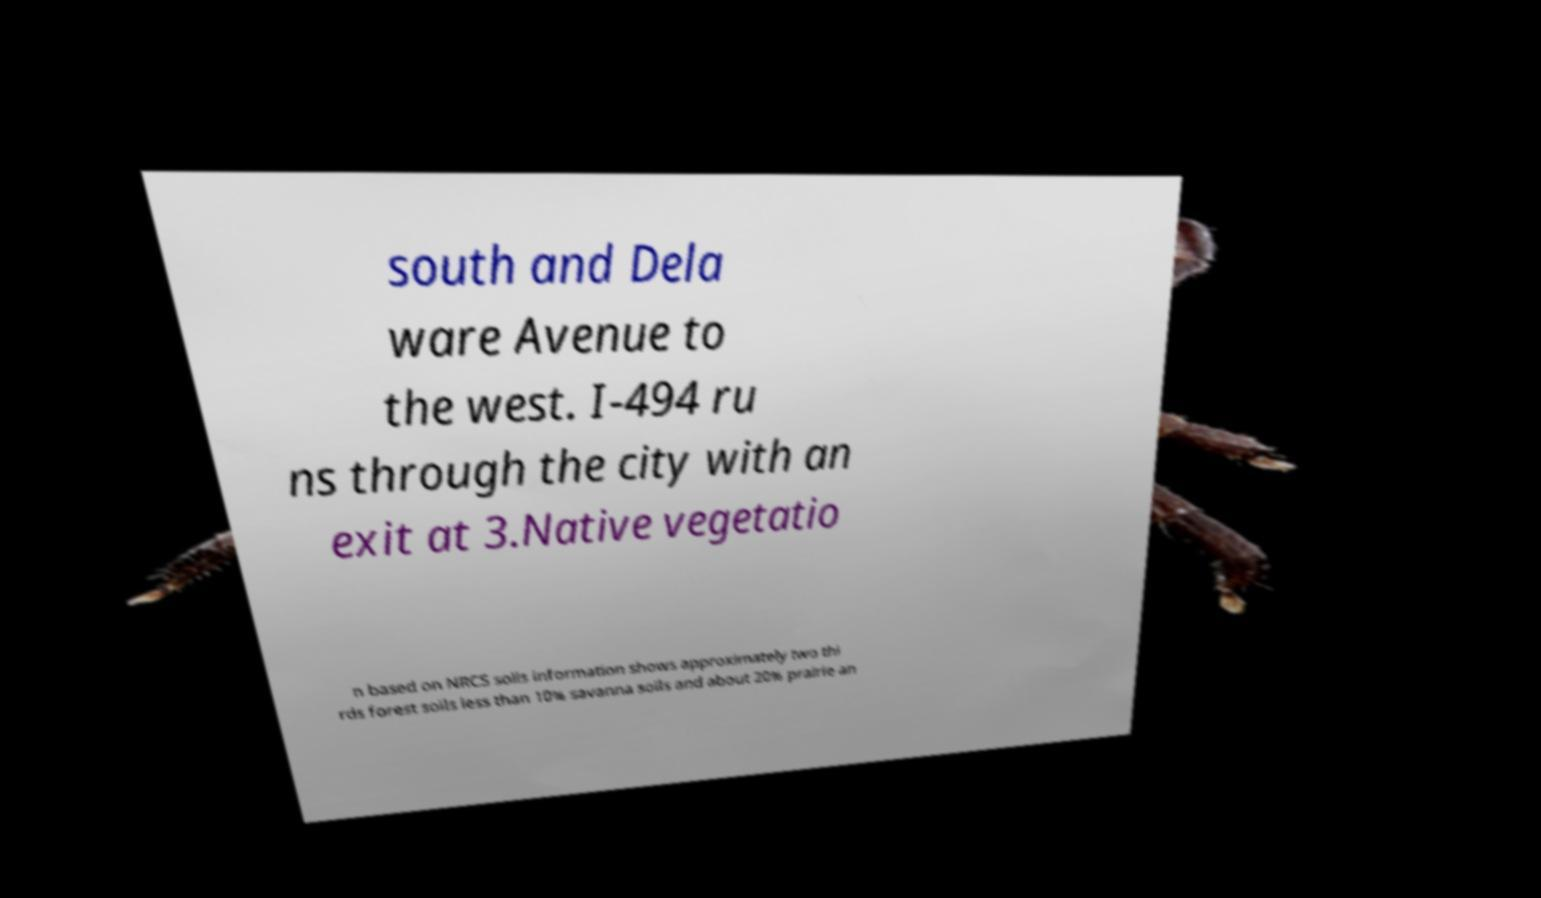Can you read and provide the text displayed in the image?This photo seems to have some interesting text. Can you extract and type it out for me? south and Dela ware Avenue to the west. I-494 ru ns through the city with an exit at 3.Native vegetatio n based on NRCS soils information shows approximately two thi rds forest soils less than 10% savanna soils and about 20% prairie an 